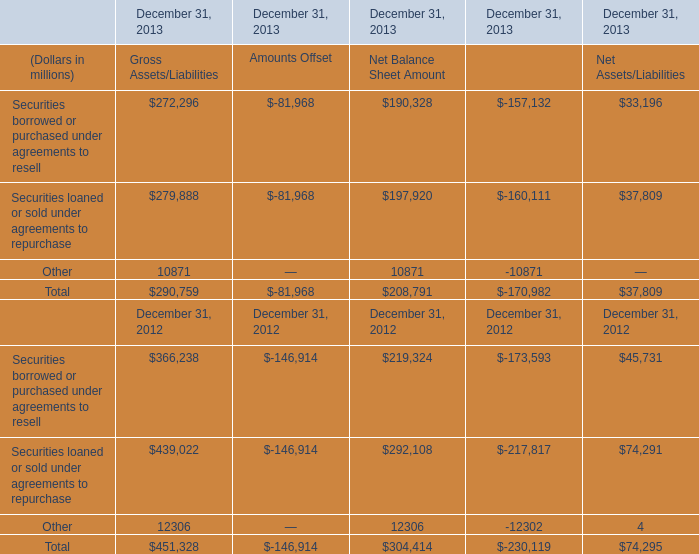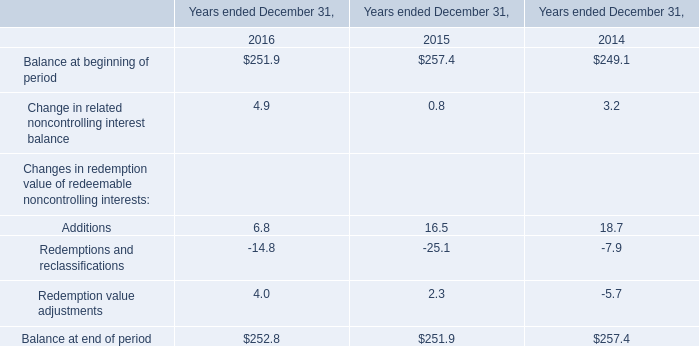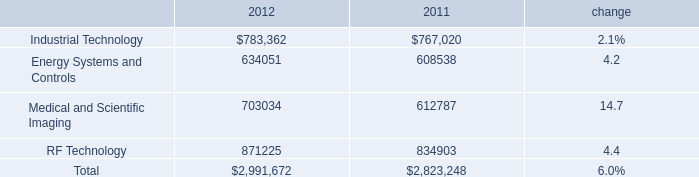What's the average of Industrial Technology of 2011, and Other of December 31, 2013 Gross Assets/Liabilities ? 
Computations: ((767020.0 + 10871.0) / 2)
Answer: 388945.5. 